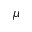Convert formula to latex. <formula><loc_0><loc_0><loc_500><loc_500>\mu</formula> 